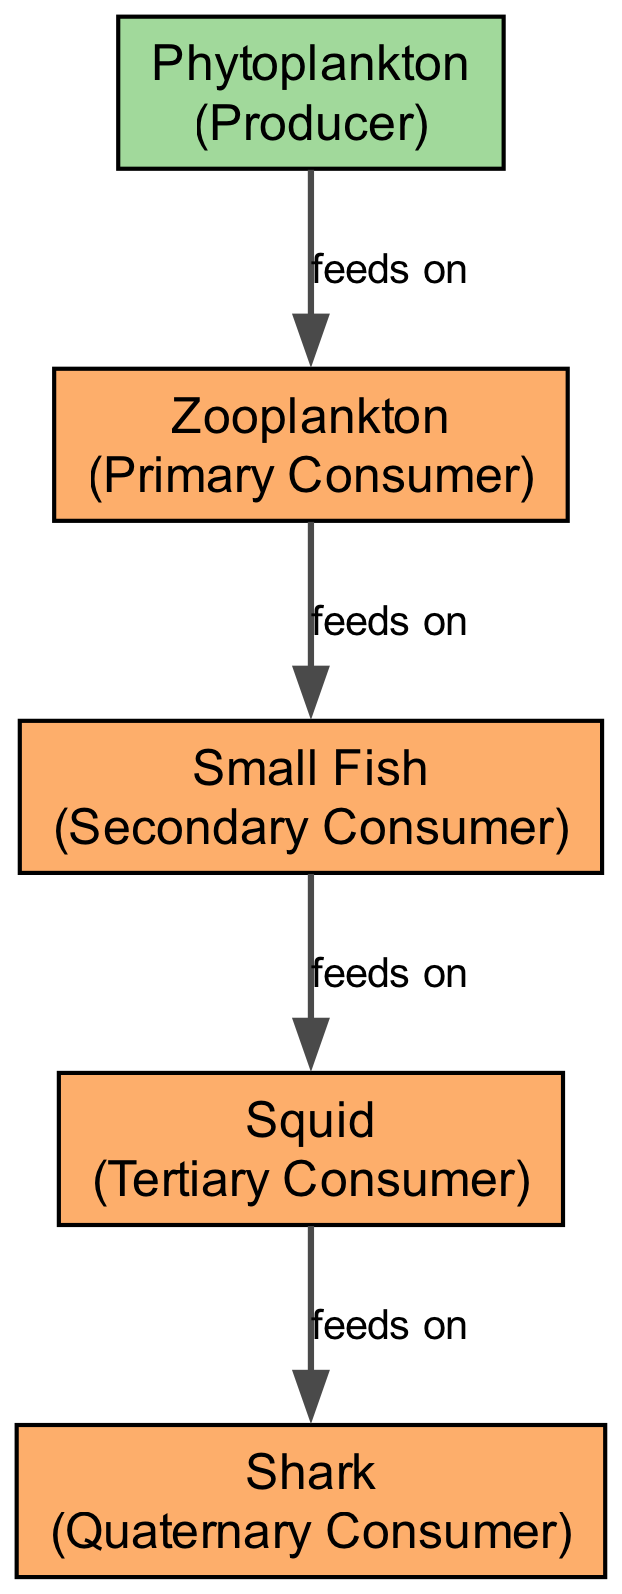What is the depth range of the Sunlit Zone? The depth range for the Sunlit Zone is specified in the diagram as 0-200m.
Answer: 0-200m How many zones are depicted in the diagram? The diagram includes three distinct zones: Sunlit Zone, Twilight Zone, and Midnight Zone, making a total of three zones.
Answer: 3 Which organism is at the top of the food chain? By following the flow of the food chain from producers to consumers, we see that the Shark is positioned as the top consumer, thus it is at the top of the food chain.
Answer: Shark What type of consumer is the Squid? The Squid is classified as a Tertiary Consumer in the diagram. This is determined by its position in the food chain, where it feeds on Small Fish, which makes it a tertiary level in the sequence.
Answer: Tertiary Consumer What does Zooplankton feed on? The diagram illustrates that Zooplankton feeds on Phytoplankton, which is indicated by the feeding relationship shown by the edge connecting them.
Answer: Phytoplankton Which zone does the Small Fish inhabit? The diagram clearly shows that the Small Fish is located in the Sunlit Zone, as indicated by the zone designation associated with this organism.
Answer: Sunlit Zone How many organisms are in the Twilight Zone? In the depicted food chain, only one organism, which is the Squid, occupies the Twilight Zone. Therefore, there is a total of one organism in that zone.
Answer: 1 What is the type of the Phytoplankton? The Phytoplankton is categorized as a Producer, which can be confirmed from its labeling shown in the diagram denoting its functional role in the food chain.
Answer: Producer What feeds on the Shark? The diagram does not show any organisms that feed on the Shark, indicating that it is at the highest level of the food chain, with no natural predators represented.
Answer: None 